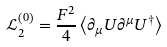Convert formula to latex. <formula><loc_0><loc_0><loc_500><loc_500>\mathcal { L } _ { 2 } ^ { \left ( 0 \right ) } = \frac { F ^ { 2 } } { 4 } \left \langle \partial _ { \mu } U \partial ^ { \mu } U ^ { \dagger } \right \rangle</formula> 